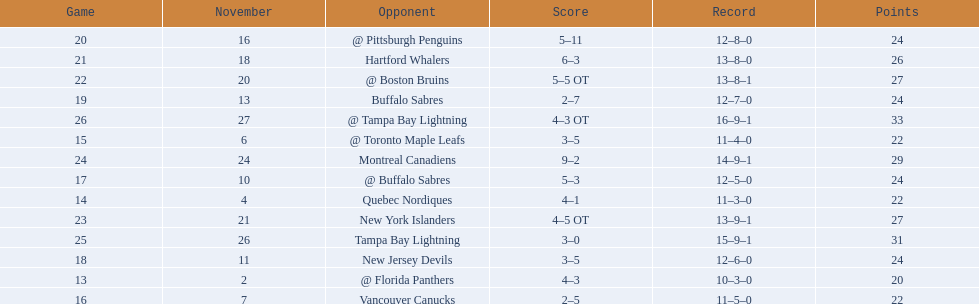Who are all of the teams? @ Florida Panthers, Quebec Nordiques, @ Toronto Maple Leafs, Vancouver Canucks, @ Buffalo Sabres, New Jersey Devils, Buffalo Sabres, @ Pittsburgh Penguins, Hartford Whalers, @ Boston Bruins, New York Islanders, Montreal Canadiens, Tampa Bay Lightning. What games finished in overtime? 22, 23, 26. In game number 23, who did they face? New York Islanders. 